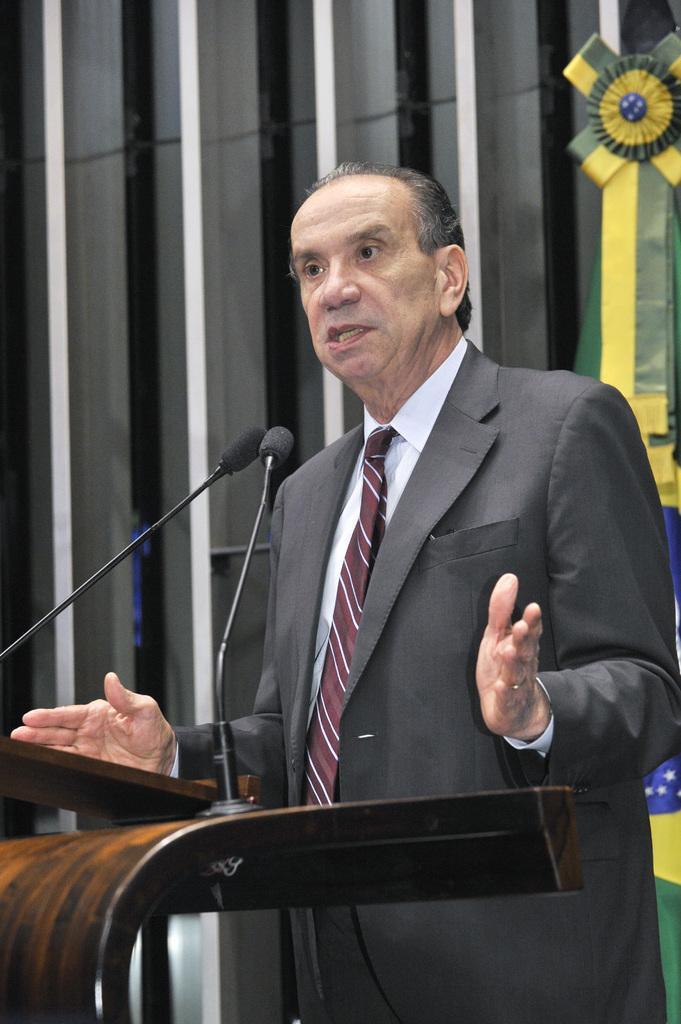How would you summarize this image in a sentence or two? In this image, we can see an old man in a suit standing near the wooden podium and talking in-front of microphones. In the background, we can see a few objects and flag. 